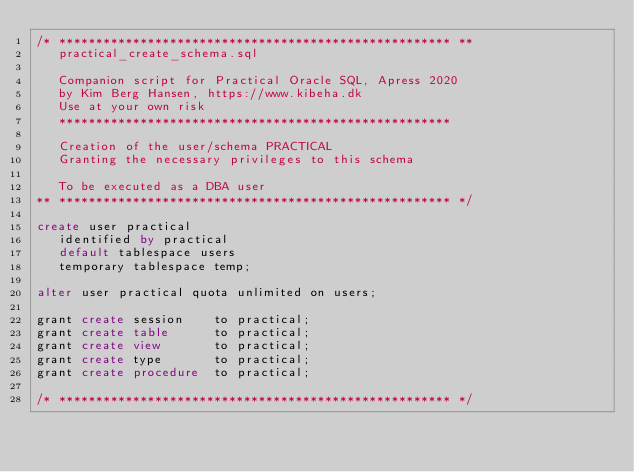Convert code to text. <code><loc_0><loc_0><loc_500><loc_500><_SQL_>/* ***************************************************** **
   practical_create_schema.sql
   
   Companion script for Practical Oracle SQL, Apress 2020
   by Kim Berg Hansen, https://www.kibeha.dk
   Use at your own risk
   *****************************************************
   
   Creation of the user/schema PRACTICAL
   Granting the necessary privileges to this schema
   
   To be executed as a DBA user
** ***************************************************** */

create user practical
   identified by practical
   default tablespace users
   temporary tablespace temp;

alter user practical quota unlimited on users;

grant create session    to practical;
grant create table      to practical;
grant create view       to practical;
grant create type       to practical;
grant create procedure  to practical;

/* ***************************************************** */
</code> 